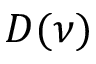Convert formula to latex. <formula><loc_0><loc_0><loc_500><loc_500>D ( \nu )</formula> 